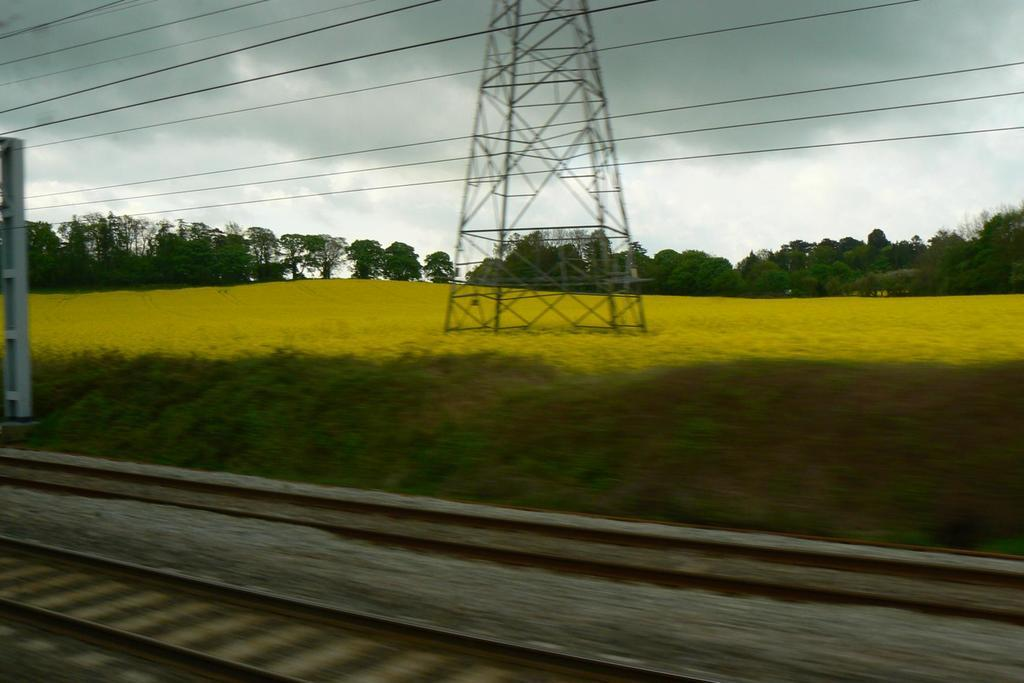What type of surface can be seen in the image? There are tracks visible in the image. What type of vegetation is present in the image? There is grass visible in the image. What structure can be seen in the image? There is a tower in the image. What else is present in the image besides the tower? There are wires visible in the image. What can be seen in the background of the image? There are trees and a cloudy sky visible in the background of the image. What type of art is displayed on the tower in the image? There is no art displayed on the tower in the image; it is a structure without any artistic elements. What type of stone is used to construct the tower in the image? There is no information about the construction material of the tower in the image, so it cannot be determined. 